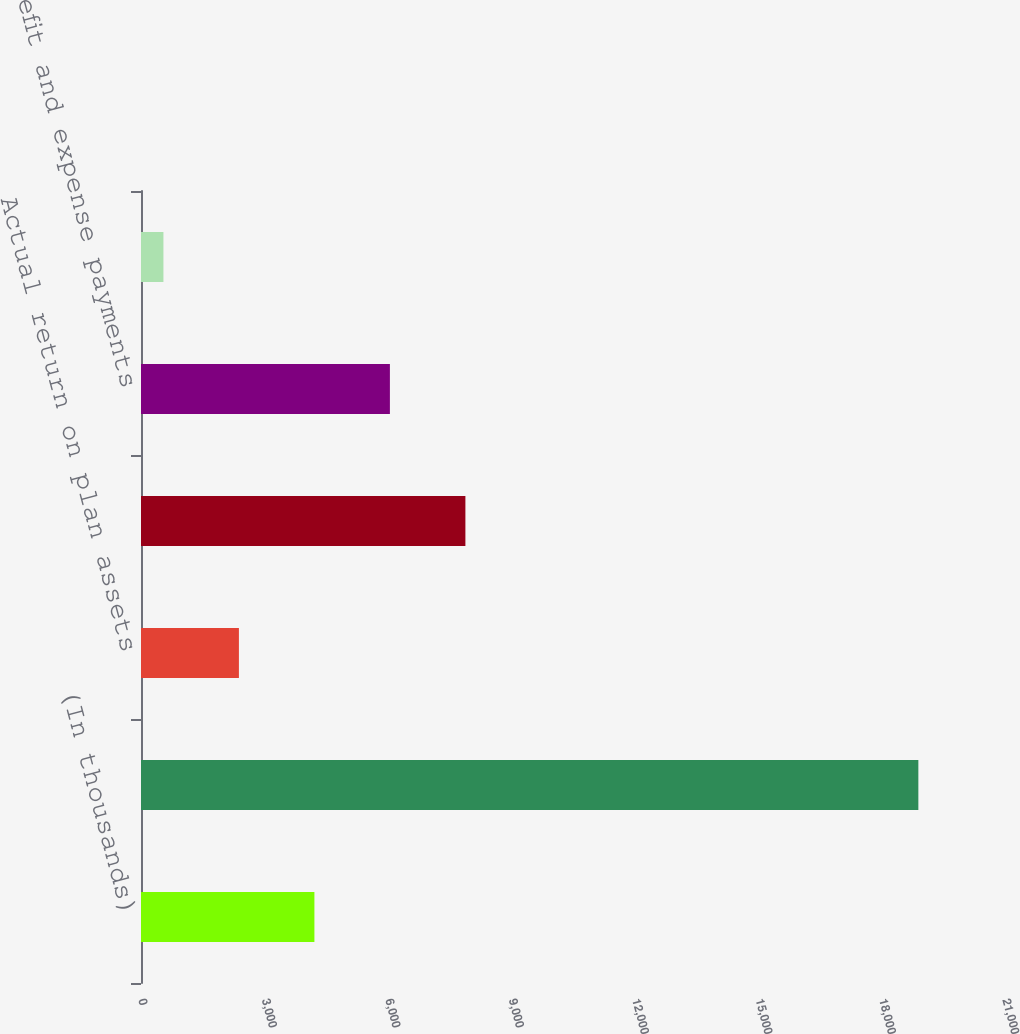Convert chart. <chart><loc_0><loc_0><loc_500><loc_500><bar_chart><fcel>(In thousands)<fcel>Fair value of plan assets as<fcel>Actual return on plan assets<fcel>Employer contributions<fcel>Benefit and expense payments<fcel>Foreign currency exchange rate<nl><fcel>4214.8<fcel>18894<fcel>2379.9<fcel>7884.6<fcel>6049.7<fcel>545<nl></chart> 